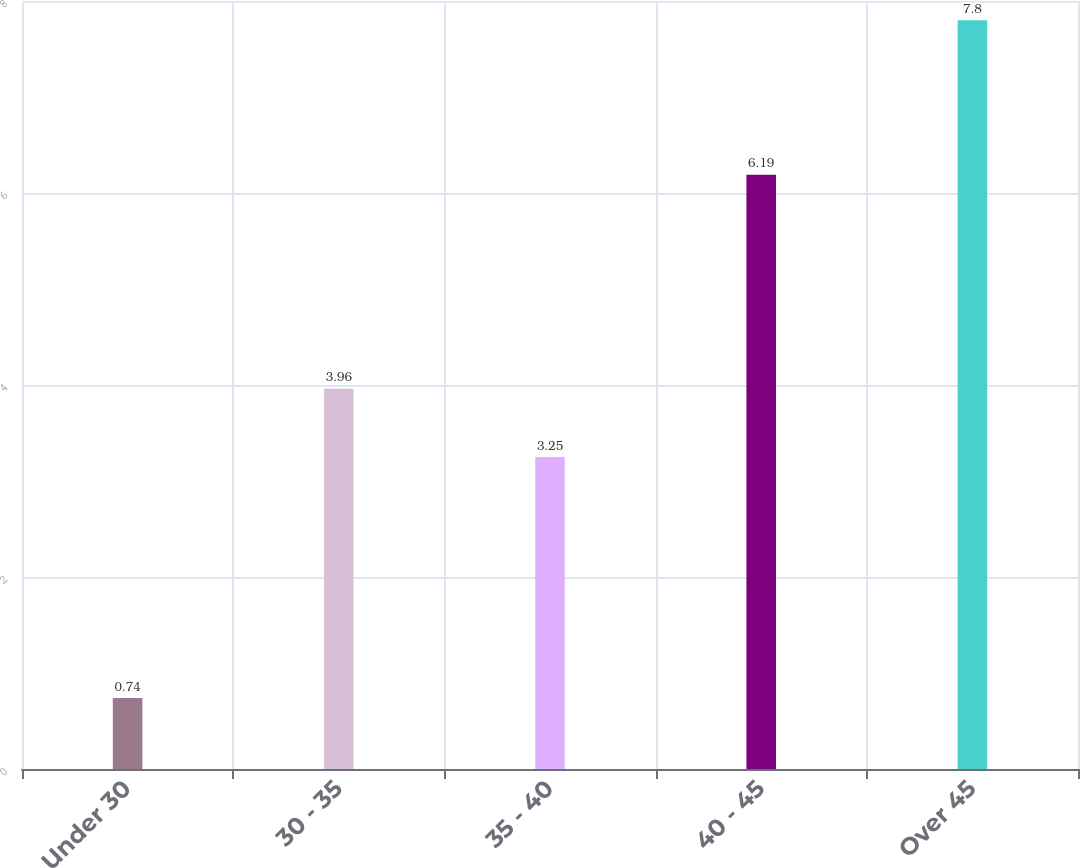<chart> <loc_0><loc_0><loc_500><loc_500><bar_chart><fcel>Under 30<fcel>30 - 35<fcel>35 - 40<fcel>40 - 45<fcel>Over 45<nl><fcel>0.74<fcel>3.96<fcel>3.25<fcel>6.19<fcel>7.8<nl></chart> 